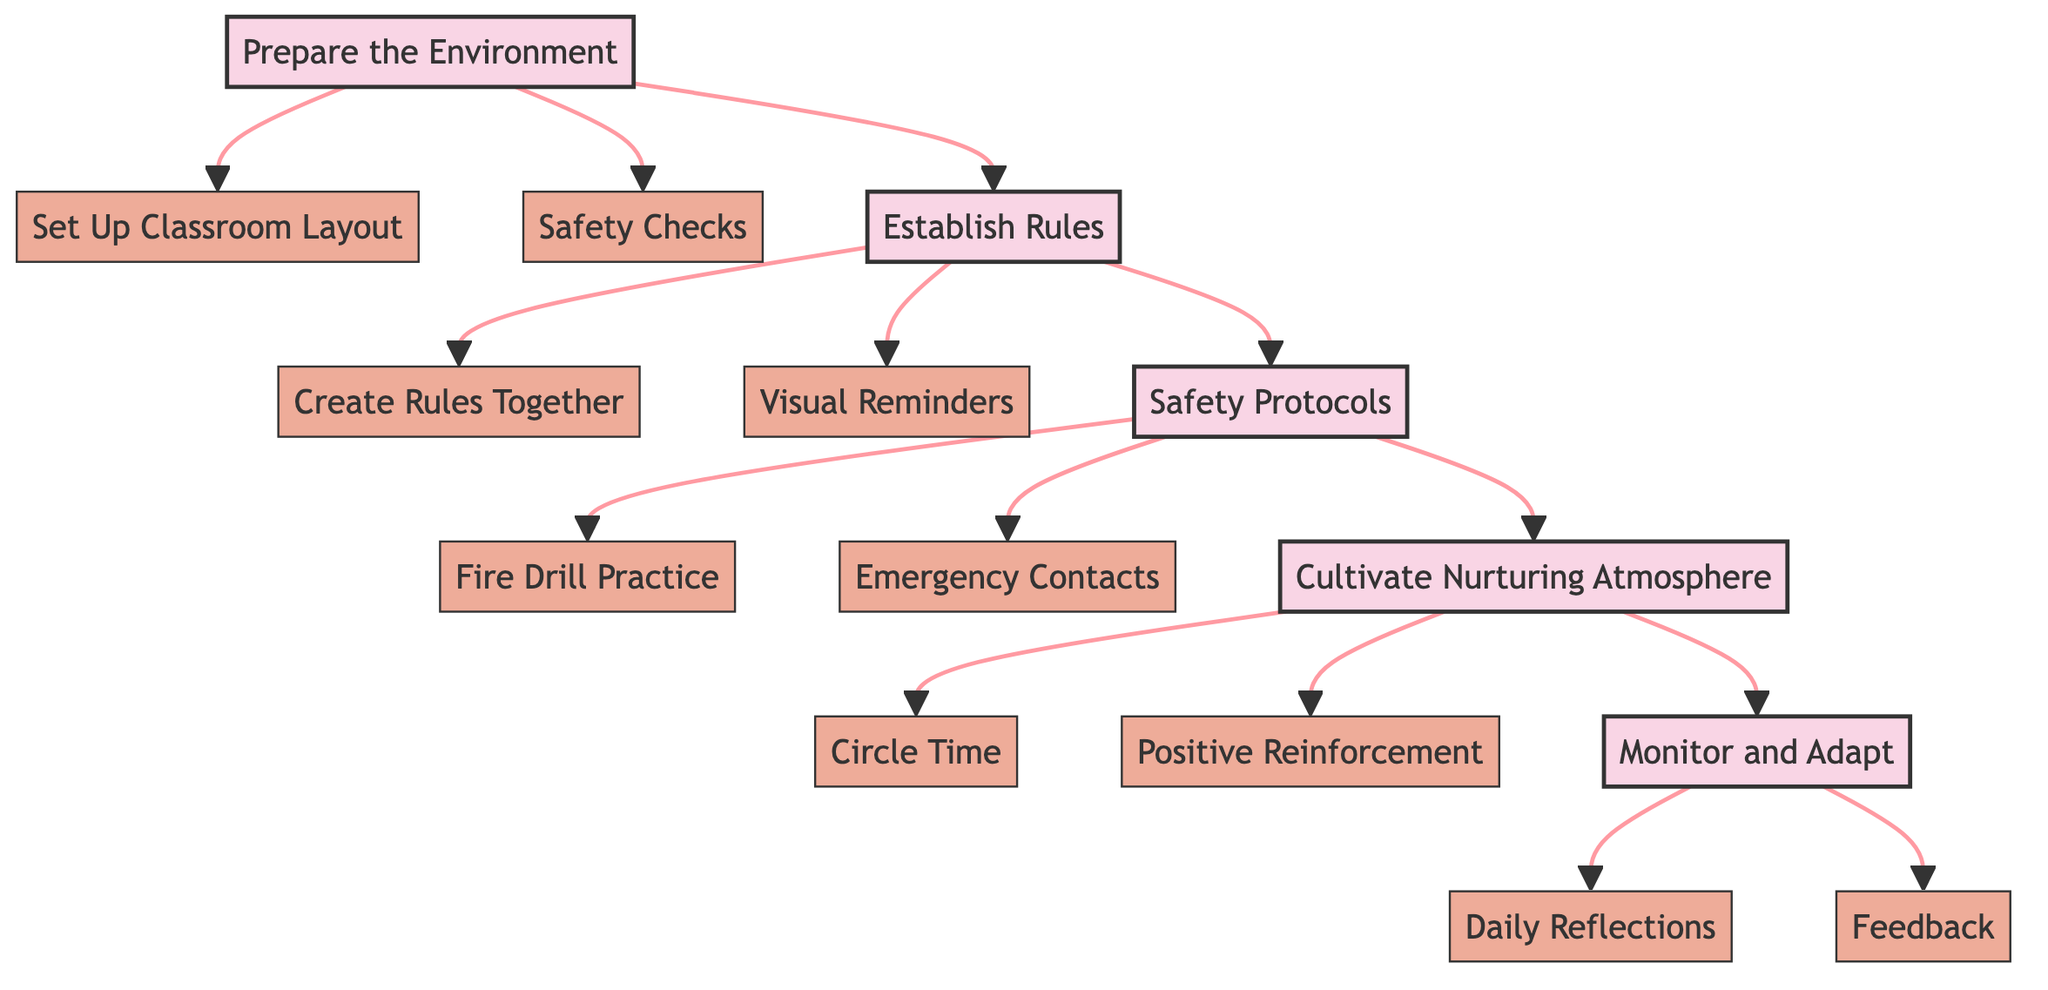What is the first step in creating a safe and welcoming classroom environment? The diagram starts with the node labeled "Prepare the Environment," indicating that this is the initial step in the process.
Answer: Prepare the Environment How many main steps are there in the flowchart? The diagram displays five main steps (Prepare the Environment, Establish Rules, Safety Protocols, Cultivate Nurturing Atmosphere, Monitor and Adapt), confirming that there are a total of five.
Answer: 5 Which step follows "Establish Rules"? From the diagram, the arrow indicates that "Safety Protocols" directly follows "Establish Rules," meaning this is the subsequent step in the flowchart.
Answer: Safety Protocols What are the two sub-steps under "Cultivate Nurturing Atmosphere"? Looking at the "Cultivate Nurturing Atmosphere" node, it branches out to "Circle Time" and "Positive Reinforcement," which are the listed sub-steps under this main step.
Answer: Circle Time, Positive Reinforcement Which safety practice involves emergency contacts? The “Emergency Contacts” node is categorized under “Safety Protocols,” showing that this practice is associated with ensuring safety in the classroom.
Answer: Emergency Contacts What is the purpose of "Daily Reflections"? This step is found under "Monitor and Adapt," and it functions to assess daily classroom experiences, thus helping to improve the classroom environment over time.
Answer: Assess daily classroom experiences What links the steps in this flowchart? Arrows in the diagram connect each main step sequentially, establishing a clear flow of procedures for creating a safe and welcoming classroom environment.
Answer: Arrows Which sub-step is related to practicing emergency protocols? The diagram indicates that "Fire Drill Practice" is the sub-step under "Safety Protocols" specifically aimed at emergency preparedness.
Answer: Fire Drill Practice 